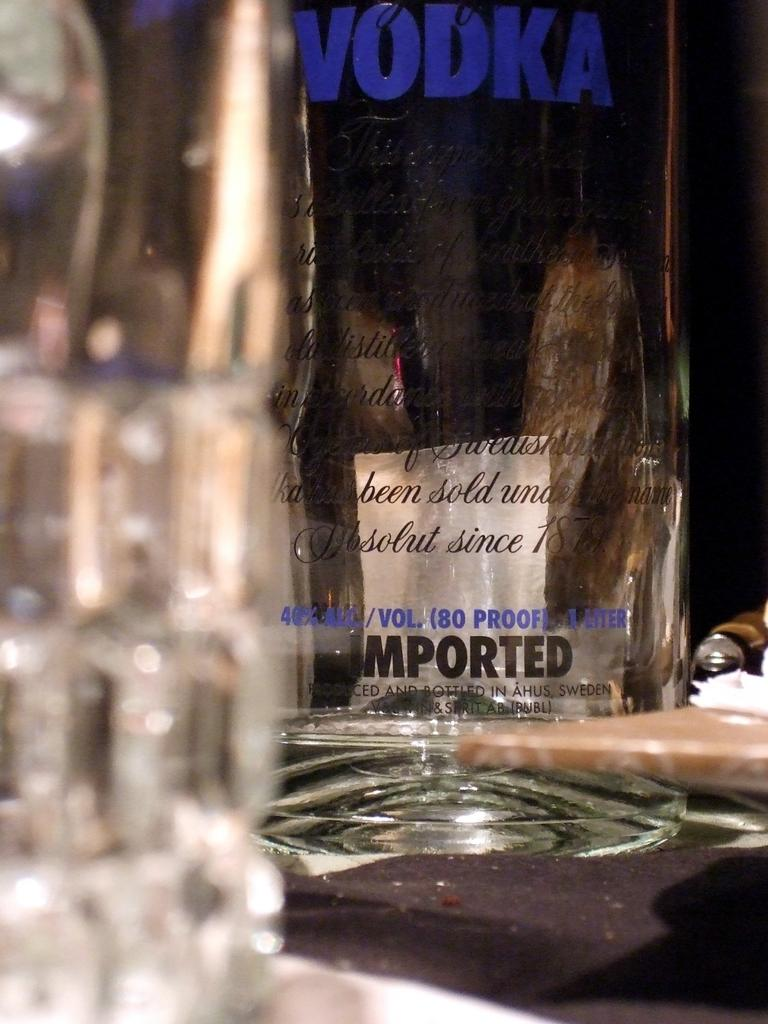What is the main object in the image? There is a vodka bottle in the image. Where is the vodka bottle located? The vodka bottle is on a table. What type of cracker is floating in the vodka bottle? There is no cracker present in the vodka bottle or the image. 